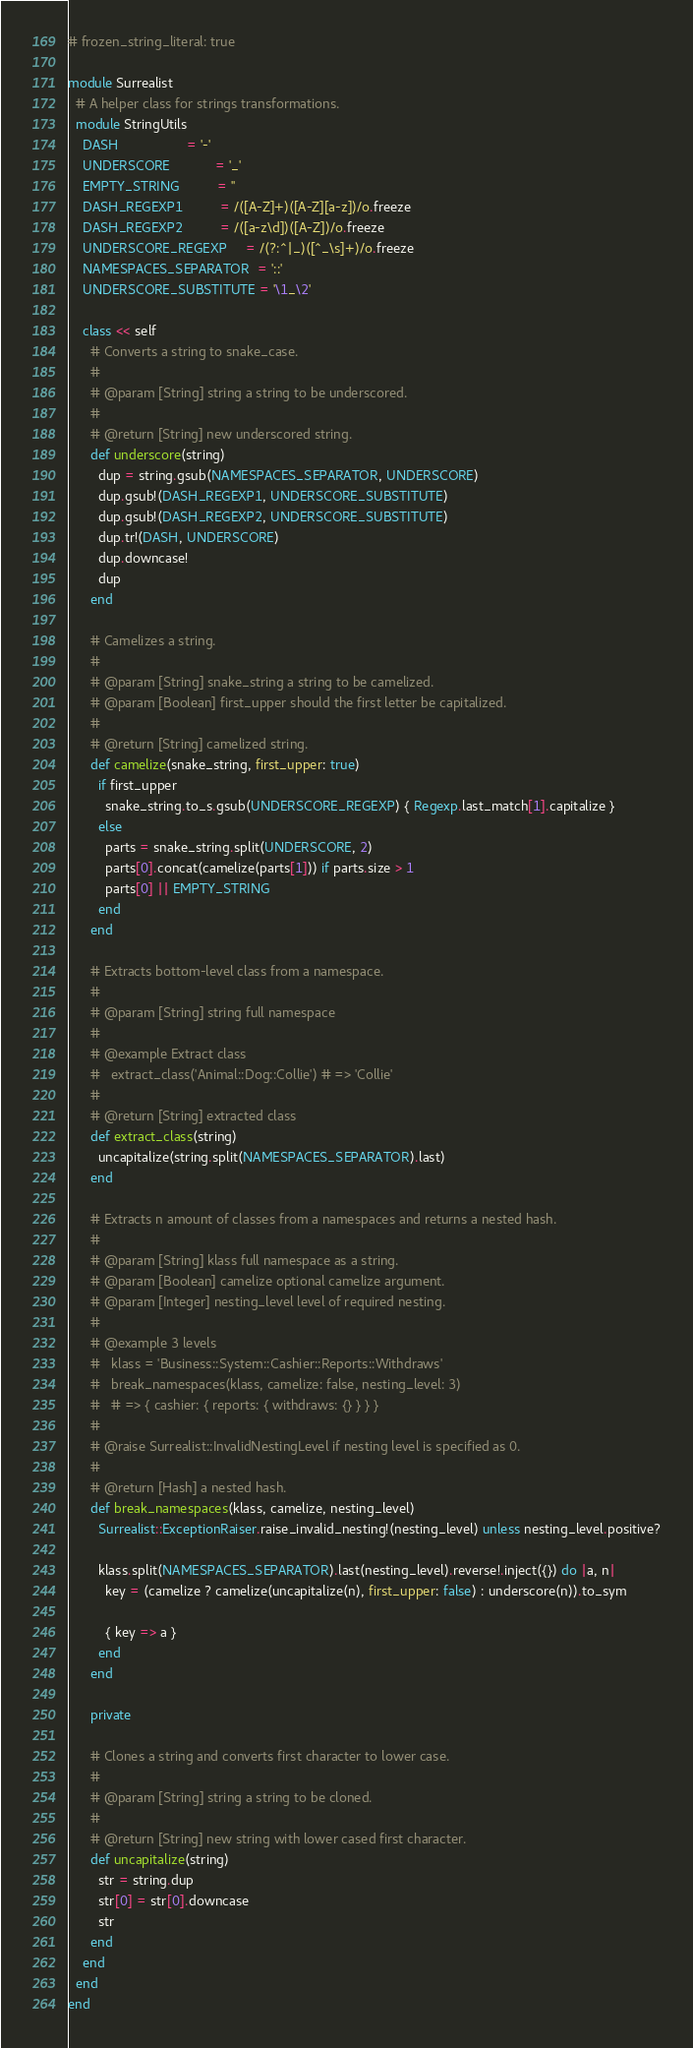Convert code to text. <code><loc_0><loc_0><loc_500><loc_500><_Ruby_># frozen_string_literal: true

module Surrealist
  # A helper class for strings transformations.
  module StringUtils
    DASH                  = '-'
    UNDERSCORE            = '_'
    EMPTY_STRING          = ''
    DASH_REGEXP1          = /([A-Z]+)([A-Z][a-z])/o.freeze
    DASH_REGEXP2          = /([a-z\d])([A-Z])/o.freeze
    UNDERSCORE_REGEXP     = /(?:^|_)([^_\s]+)/o.freeze
    NAMESPACES_SEPARATOR  = '::'
    UNDERSCORE_SUBSTITUTE = '\1_\2'

    class << self
      # Converts a string to snake_case.
      #
      # @param [String] string a string to be underscored.
      #
      # @return [String] new underscored string.
      def underscore(string)
        dup = string.gsub(NAMESPACES_SEPARATOR, UNDERSCORE)
        dup.gsub!(DASH_REGEXP1, UNDERSCORE_SUBSTITUTE)
        dup.gsub!(DASH_REGEXP2, UNDERSCORE_SUBSTITUTE)
        dup.tr!(DASH, UNDERSCORE)
        dup.downcase!
        dup
      end

      # Camelizes a string.
      #
      # @param [String] snake_string a string to be camelized.
      # @param [Boolean] first_upper should the first letter be capitalized.
      #
      # @return [String] camelized string.
      def camelize(snake_string, first_upper: true)
        if first_upper
          snake_string.to_s.gsub(UNDERSCORE_REGEXP) { Regexp.last_match[1].capitalize }
        else
          parts = snake_string.split(UNDERSCORE, 2)
          parts[0].concat(camelize(parts[1])) if parts.size > 1
          parts[0] || EMPTY_STRING
        end
      end

      # Extracts bottom-level class from a namespace.
      #
      # @param [String] string full namespace
      #
      # @example Extract class
      #   extract_class('Animal::Dog::Collie') # => 'Collie'
      #
      # @return [String] extracted class
      def extract_class(string)
        uncapitalize(string.split(NAMESPACES_SEPARATOR).last)
      end

      # Extracts n amount of classes from a namespaces and returns a nested hash.
      #
      # @param [String] klass full namespace as a string.
      # @param [Boolean] camelize optional camelize argument.
      # @param [Integer] nesting_level level of required nesting.
      #
      # @example 3 levels
      #   klass = 'Business::System::Cashier::Reports::Withdraws'
      #   break_namespaces(klass, camelize: false, nesting_level: 3)
      #   # => { cashier: { reports: { withdraws: {} } } }
      #
      # @raise Surrealist::InvalidNestingLevel if nesting level is specified as 0.
      #
      # @return [Hash] a nested hash.
      def break_namespaces(klass, camelize, nesting_level)
        Surrealist::ExceptionRaiser.raise_invalid_nesting!(nesting_level) unless nesting_level.positive?

        klass.split(NAMESPACES_SEPARATOR).last(nesting_level).reverse!.inject({}) do |a, n|
          key = (camelize ? camelize(uncapitalize(n), first_upper: false) : underscore(n)).to_sym

          { key => a }
        end
      end

      private

      # Clones a string and converts first character to lower case.
      #
      # @param [String] string a string to be cloned.
      #
      # @return [String] new string with lower cased first character.
      def uncapitalize(string)
        str = string.dup
        str[0] = str[0].downcase
        str
      end
    end
  end
end
</code> 